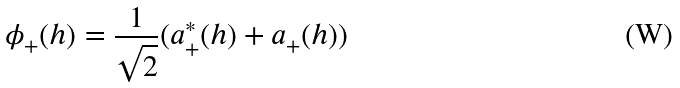<formula> <loc_0><loc_0><loc_500><loc_500>\phi _ { + } ( h ) = \frac { 1 } { \sqrt { 2 } } ( a _ { + } ^ { * } ( h ) + a _ { + } ( h ) )</formula> 